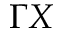Convert formula to latex. <formula><loc_0><loc_0><loc_500><loc_500>\Gamma X</formula> 